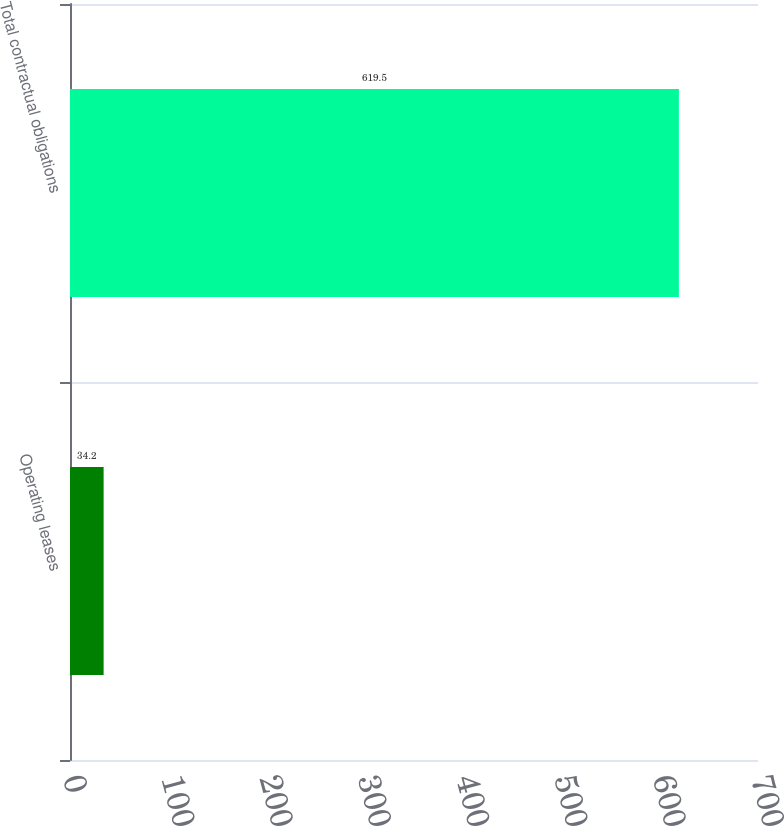Convert chart to OTSL. <chart><loc_0><loc_0><loc_500><loc_500><bar_chart><fcel>Operating leases<fcel>Total contractual obligations<nl><fcel>34.2<fcel>619.5<nl></chart> 